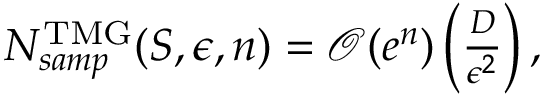<formula> <loc_0><loc_0><loc_500><loc_500>\begin{array} { r } { N _ { s a m p } ^ { T M G } ( S , \epsilon , n ) = \mathcal { O } ( e ^ { n } ) \left ( \frac { D } { \epsilon ^ { 2 } } \right ) , } \end{array}</formula> 